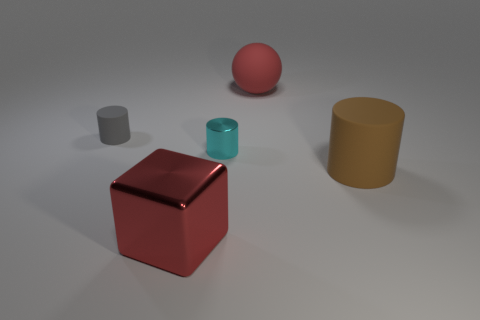Are there any other things that are the same shape as the red matte thing?
Your answer should be compact. No. Is the shape of the red thing behind the tiny matte object the same as  the gray thing?
Offer a very short reply. No. The large block that is made of the same material as the cyan object is what color?
Your response must be concise. Red. There is a small cylinder on the left side of the large red metallic object; what is its material?
Make the answer very short. Rubber. Do the gray thing and the large red object that is right of the big red shiny thing have the same shape?
Provide a short and direct response. No. What material is the cylinder that is both left of the red matte thing and right of the small gray thing?
Provide a succinct answer. Metal. There is a metallic block that is the same size as the sphere; what color is it?
Your answer should be very brief. Red. Are the cyan cylinder and the red object behind the large brown object made of the same material?
Your answer should be very brief. No. How many other things are the same size as the gray matte cylinder?
Your response must be concise. 1. Are there any red shiny things left of the big red object to the right of the metallic thing that is on the left side of the small cyan cylinder?
Ensure brevity in your answer.  Yes. 